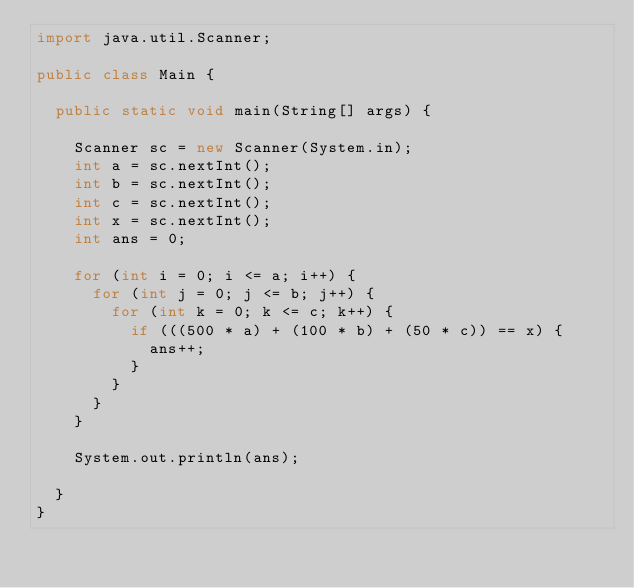Convert code to text. <code><loc_0><loc_0><loc_500><loc_500><_Java_>import java.util.Scanner;

public class Main {

  public static void main(String[] args) {

    Scanner sc = new Scanner(System.in);
    int a = sc.nextInt();
    int b = sc.nextInt();
    int c = sc.nextInt();
    int x = sc.nextInt();
    int ans = 0;

    for (int i = 0; i <= a; i++) {
      for (int j = 0; j <= b; j++) {
        for (int k = 0; k <= c; k++) {
          if (((500 * a) + (100 * b) + (50 * c)) == x) {
            ans++;
          }
        }
      }
    }

    System.out.println(ans);

  }
}</code> 